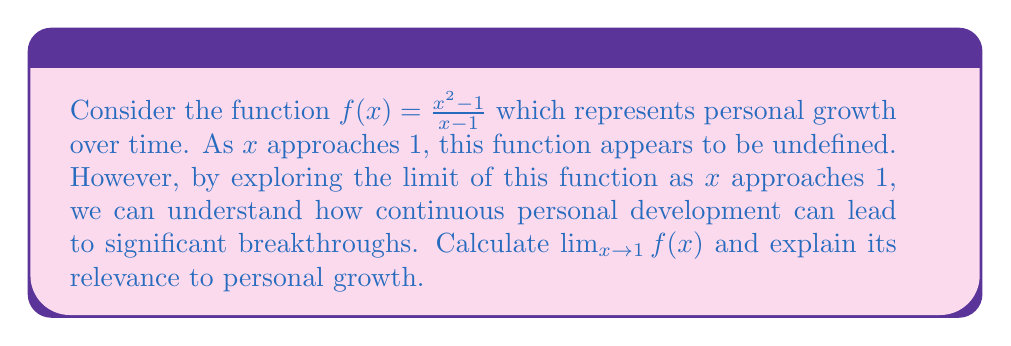Give your solution to this math problem. To find the limit of $f(x) = \frac{x^2 - 1}{x - 1}$ as $x$ approaches 1, we need to use the following steps:

1) First, we observe that the function is undefined at $x = 1$ because the denominator becomes zero. However, we can still evaluate the limit.

2) We can factor the numerator:
   $$f(x) = \frac{x^2 - 1}{x - 1} = \frac{(x+1)(x-1)}{x - 1}$$

3) Now we can cancel the $(x-1)$ term in the numerator and denominator:
   $$\lim_{x \to 1} f(x) = \lim_{x \to 1} \frac{(x+1)(x-1)}{x - 1} = \lim_{x \to 1} (x+1)$$

4) As $x$ approaches 1, $(x+1)$ approaches 2:
   $$\lim_{x \to 1} (x+1) = 2$$

This result can be interpreted in terms of personal growth. The original function appears to have a discontinuity at $x = 1$, which might represent a challenging period in one's life. However, by carefully examining the limit, we find that the function actually approaches a definite value (2) as we get closer to this point.

This mirrors the process of personal growth through difficult times. Even when progress seems impossible (like when a function seems undefined), continuous effort and self-reflection (represented by taking the limit) can lead to significant breakthroughs and personal development (reaching the limit value of 2).

The limit value of 2 could symbolize a new, higher level of personal growth achieved after working through challenges. This demonstrates that what initially appears as an insurmountable obstacle can become a stepping stone to greater personal development when approached with persistence and the right perspective.
Answer: $\lim_{x \to 1} \frac{x^2 - 1}{x - 1} = 2$ 